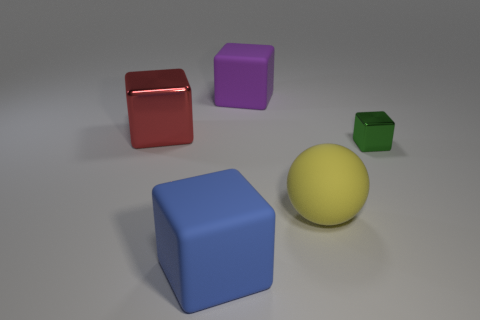Subtract all purple matte cubes. How many cubes are left? 3 Subtract all green cubes. How many cubes are left? 3 Add 1 metallic blocks. How many objects exist? 6 Subtract 1 spheres. How many spheres are left? 0 Add 1 big gray metallic cubes. How many big gray metallic cubes exist? 1 Subtract 1 yellow spheres. How many objects are left? 4 Subtract all blocks. How many objects are left? 1 Subtract all cyan blocks. Subtract all gray spheres. How many blocks are left? 4 Subtract all yellow blocks. How many blue spheres are left? 0 Subtract all large things. Subtract all yellow matte balls. How many objects are left? 0 